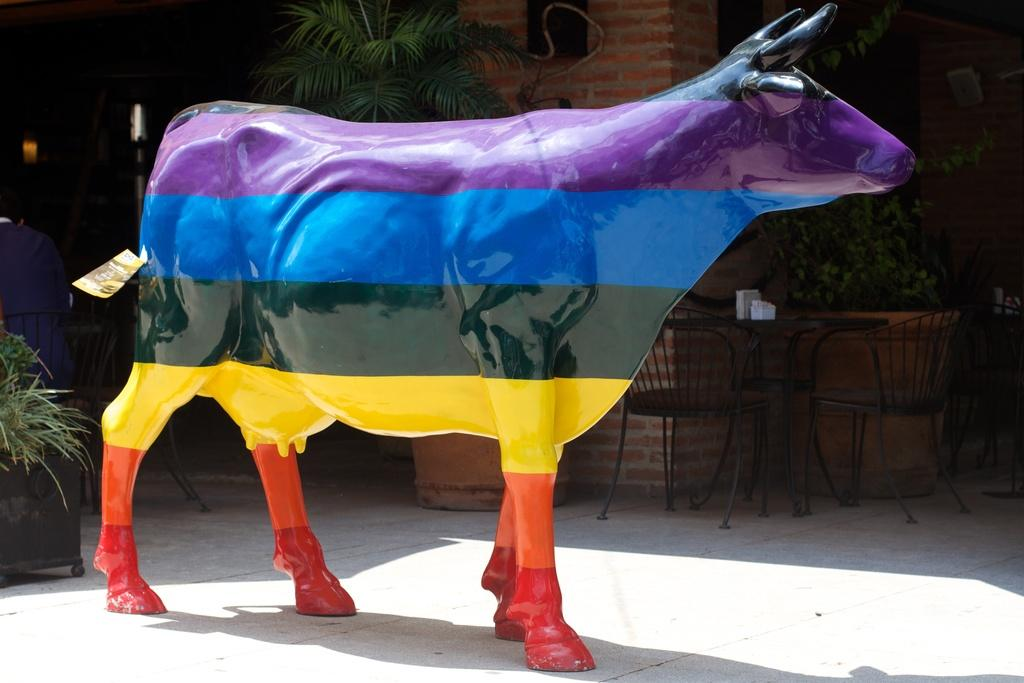What type of animal is depicted as a statue in the image? There is a statue of a cow in the image. How is the cow statue decorated? The statue is multi-colored. What piece of furniture is in the middle of the image? There is a chair in the middle of the image. What type of vegetation can be seen on the left side of the image? There are plants on the left side of the image. Are there any plants visible in a different location in the image? Yes, there are plants on the top of the image. How many bells are attached to the cow statue in the image? There are no bells attached to the cow statue in the image. What type of muscle is visible on the cow statue in the image? There is no muscle visible on the cow statue in the image, as it is a statue and not a living animal. 